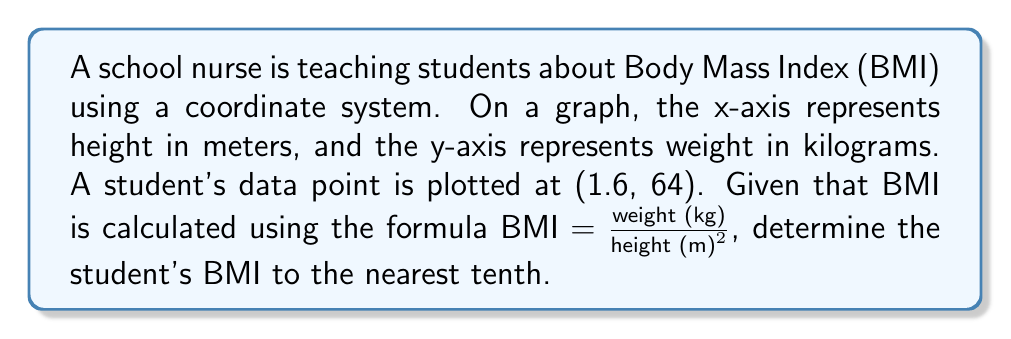Provide a solution to this math problem. To solve this problem, we'll follow these steps:

1. Identify the coordinates:
   x-coordinate (height) = 1.6 m
   y-coordinate (weight) = 64 kg

2. Apply the BMI formula:
   $BMI = \frac{weight (kg)}{height (m)^2}$

3. Substitute the values:
   $BMI = \frac{64}{1.6^2}$

4. Calculate:
   $BMI = \frac{64}{2.56}$
   $BMI = 25$

5. Round to the nearest tenth:
   The BMI is already a whole number, so it remains 25.0.

This coordinate system approach allows students to visualize the relationship between height and weight while learning how to calculate BMI.
Answer: The student's BMI is 25.0. 